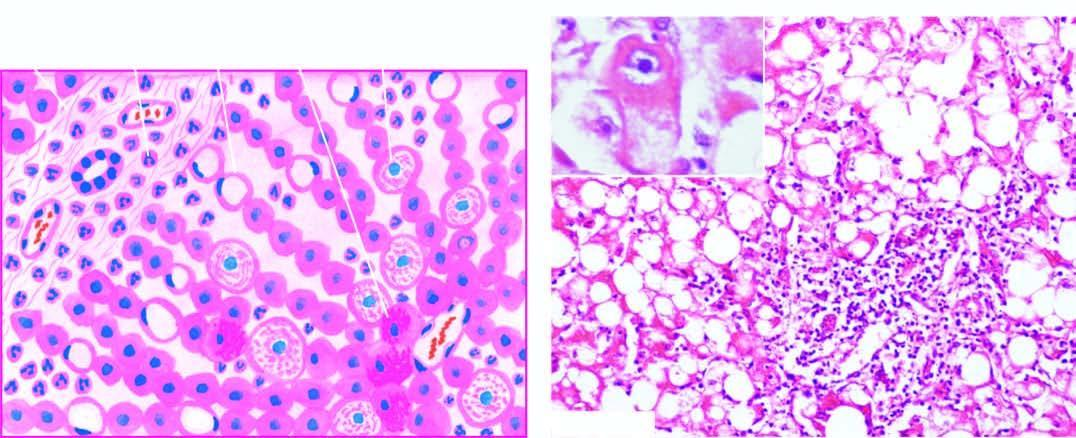what are also present?
Answer the question using a single word or phrase. Fatty change and clusters of neutrophils 